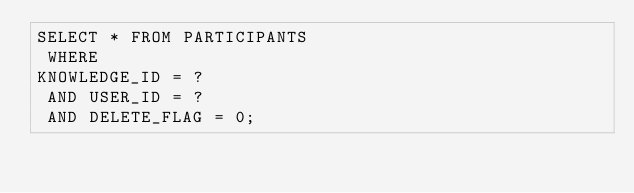Convert code to text. <code><loc_0><loc_0><loc_500><loc_500><_SQL_>SELECT * FROM PARTICIPANTS
 WHERE 
KNOWLEDGE_ID = ?
 AND USER_ID = ?
 AND DELETE_FLAG = 0;
</code> 